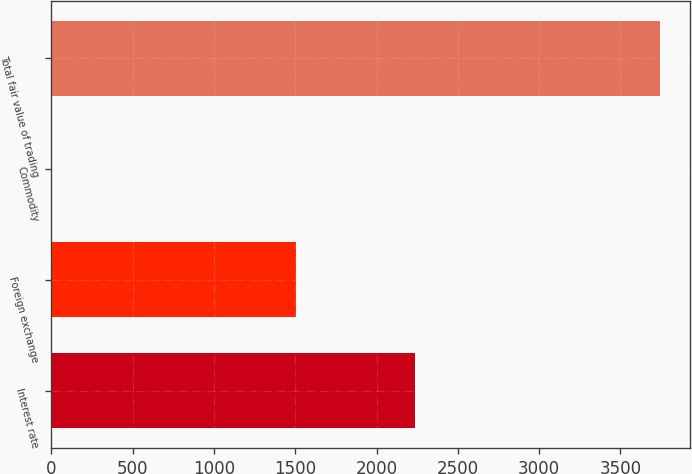Convert chart. <chart><loc_0><loc_0><loc_500><loc_500><bar_chart><fcel>Interest rate<fcel>Foreign exchange<fcel>Commodity<fcel>Total fair value of trading<nl><fcel>2238<fcel>1503<fcel>1<fcel>3742<nl></chart> 